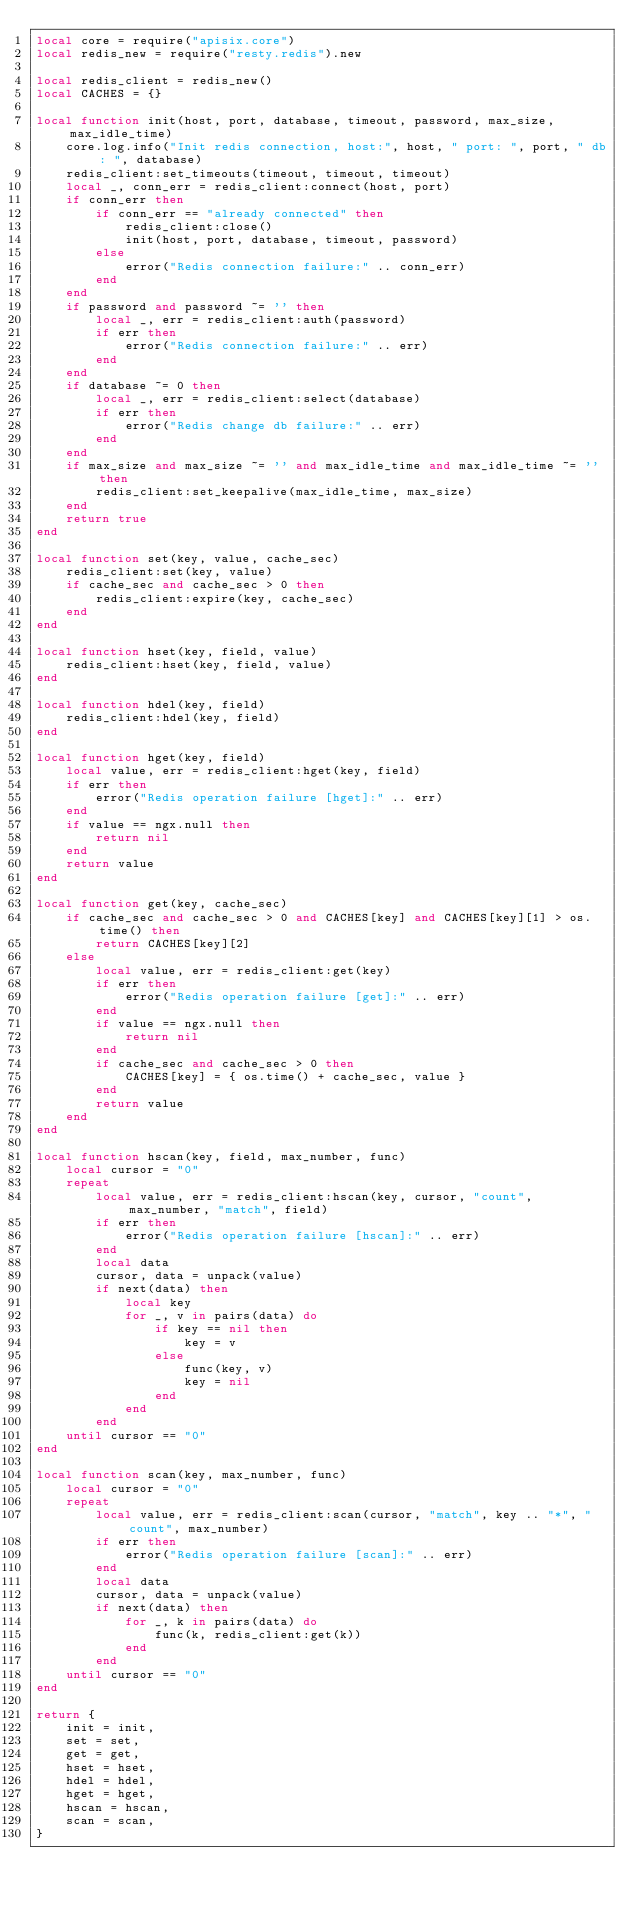<code> <loc_0><loc_0><loc_500><loc_500><_Lua_>local core = require("apisix.core")
local redis_new = require("resty.redis").new

local redis_client = redis_new()
local CACHES = {}

local function init(host, port, database, timeout, password, max_size, max_idle_time)
    core.log.info("Init redis connection, host:", host, " port: ", port, " db: ", database)
    redis_client:set_timeouts(timeout, timeout, timeout)
    local _, conn_err = redis_client:connect(host, port)
    if conn_err then
        if conn_err == "already connected" then
            redis_client:close()
            init(host, port, database, timeout, password)
        else
            error("Redis connection failure:" .. conn_err)
        end
    end
    if password and password ~= '' then
        local _, err = redis_client:auth(password)
        if err then
            error("Redis connection failure:" .. err)
        end
    end
    if database ~= 0 then
        local _, err = redis_client:select(database)
        if err then
            error("Redis change db failure:" .. err)
        end
    end
    if max_size and max_size ~= '' and max_idle_time and max_idle_time ~= '' then
        redis_client:set_keepalive(max_idle_time, max_size)
    end
    return true
end

local function set(key, value, cache_sec)
    redis_client:set(key, value)
    if cache_sec and cache_sec > 0 then
        redis_client:expire(key, cache_sec)
    end
end

local function hset(key, field, value)
    redis_client:hset(key, field, value)
end

local function hdel(key, field)
    redis_client:hdel(key, field)
end

local function hget(key, field)
    local value, err = redis_client:hget(key, field)
    if err then
        error("Redis operation failure [hget]:" .. err)
    end
    if value == ngx.null then
        return nil
    end
    return value
end

local function get(key, cache_sec)
    if cache_sec and cache_sec > 0 and CACHES[key] and CACHES[key][1] > os.time() then
        return CACHES[key][2]
    else
        local value, err = redis_client:get(key)
        if err then
            error("Redis operation failure [get]:" .. err)
        end
        if value == ngx.null then
            return nil
        end
        if cache_sec and cache_sec > 0 then
            CACHES[key] = { os.time() + cache_sec, value }
        end
        return value
    end
end

local function hscan(key, field, max_number, func)
    local cursor = "0"
    repeat
        local value, err = redis_client:hscan(key, cursor, "count", max_number, "match", field)
        if err then
            error("Redis operation failure [hscan]:" .. err)
        end
        local data
        cursor, data = unpack(value)
        if next(data) then
            local key
            for _, v in pairs(data) do
                if key == nil then
                    key = v
                else
                    func(key, v)
                    key = nil
                end
            end
        end
    until cursor == "0"
end

local function scan(key, max_number, func)
    local cursor = "0"
    repeat
        local value, err = redis_client:scan(cursor, "match", key .. "*", "count", max_number)
        if err then
            error("Redis operation failure [scan]:" .. err)
        end
        local data
        cursor, data = unpack(value)
        if next(data) then
            for _, k in pairs(data) do
                func(k, redis_client:get(k))
            end
        end
    until cursor == "0"
end

return {
    init = init,
    set = set,
    get = get,
    hset = hset,
    hdel = hdel,
    hget = hget,
    hscan = hscan,
    scan = scan,
}</code> 